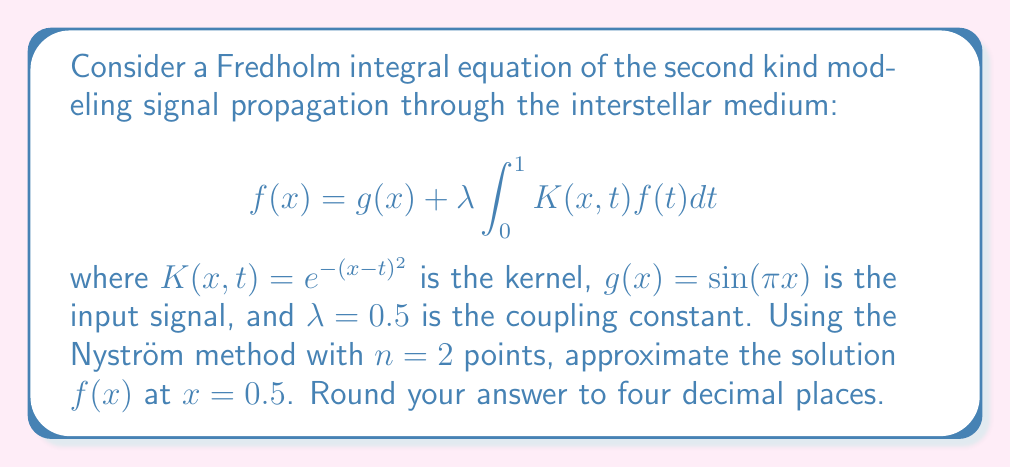Show me your answer to this math problem. To solve this problem, we'll follow these steps:

1) The Nyström method approximates the integral using a quadrature rule. For $n=2$, we'll use the trapezoidal rule with equally spaced points.

2) The quadrature points are $x_1 = 0$ and $x_2 = 1$, with weights $w_1 = w_2 = 0.5$.

3) We replace the integral equation with a system of linear equations:

   $$f(x_i) = g(x_i) + \lambda \sum_{j=1}^2 w_j K(x_i,x_j)f(x_j)$$

   for $i = 1, 2$

4) This gives us:

   $$f(0) = \sin(0) + 0.5 [0.5e^{-0^2}f(0) + 0.5e^{-1^2}f(1)]$$
   $$f(1) = \sin(\pi) + 0.5 [0.5e^{-1^2}f(0) + 0.5e^{-0^2}f(1)]$$

5) Simplify:

   $$f(0) = 0.25f(0) + 0.25e^{-1}f(1)$$
   $$f(1) = 0.25e^{-1}f(0) + 0.25f(1)$$

6) Solve this system of linear equations:

   $$0.75f(0) - 0.25e^{-1}f(1) = 0$$
   $$-0.25e^{-1}f(0) + 0.75f(1) = 0$$

7) The solution is $f(0) = f(1) = 0$.

8) Now, to find $f(0.5)$, we use the original equation:

   $$f(0.5) = \sin(0.5\pi) + 0.5 [0.5K(0.5,0)f(0) + 0.5K(0.5,1)f(1)]$$

9) Substitute the known values:

   $$f(0.5) = \sin(0.5\pi) + 0.5 [0.5e^{-(0.5-0)^2} \cdot 0 + 0.5e^{-(0.5-1)^2} \cdot 0]$$

10) Simplify:

    $$f(0.5) = \sin(0.5\pi) = 1$$

Therefore, the approximated value of $f(0.5)$ is 1.0000.
Answer: 1.0000 